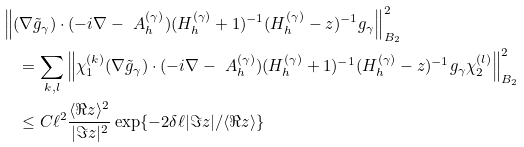Convert formula to latex. <formula><loc_0><loc_0><loc_500><loc_500>& \left \| ( \nabla \tilde { g } _ { \gamma } ) \cdot ( - i \nabla - \ A _ { h } ^ { ( \gamma ) } ) ( H _ { h } ^ { ( \gamma ) } + 1 ) ^ { - 1 } ( H _ { h } ^ { ( \gamma ) } - z ) ^ { - 1 } g _ { \gamma } \right \| _ { B _ { 2 } } ^ { 2 } \\ & \quad = \sum _ { k , l } \left \| \chi _ { 1 } ^ { ( k ) } ( \nabla \tilde { g } _ { \gamma } ) \cdot ( - i \nabla - \ A _ { h } ^ { ( \gamma ) } ) ( H _ { h } ^ { ( \gamma ) } + 1 ) ^ { - 1 } ( H _ { h } ^ { ( \gamma ) } - z ) ^ { - 1 } g _ { \gamma } \chi _ { 2 } ^ { ( l ) } \right \| _ { B _ { 2 } } ^ { 2 } \\ & \quad \leq C \ell ^ { 2 } \frac { \langle \Re z \rangle ^ { 2 } } { | \Im z | ^ { 2 } } \exp \{ - 2 \delta \ell | \Im z | / \langle \Re z \rangle \}</formula> 